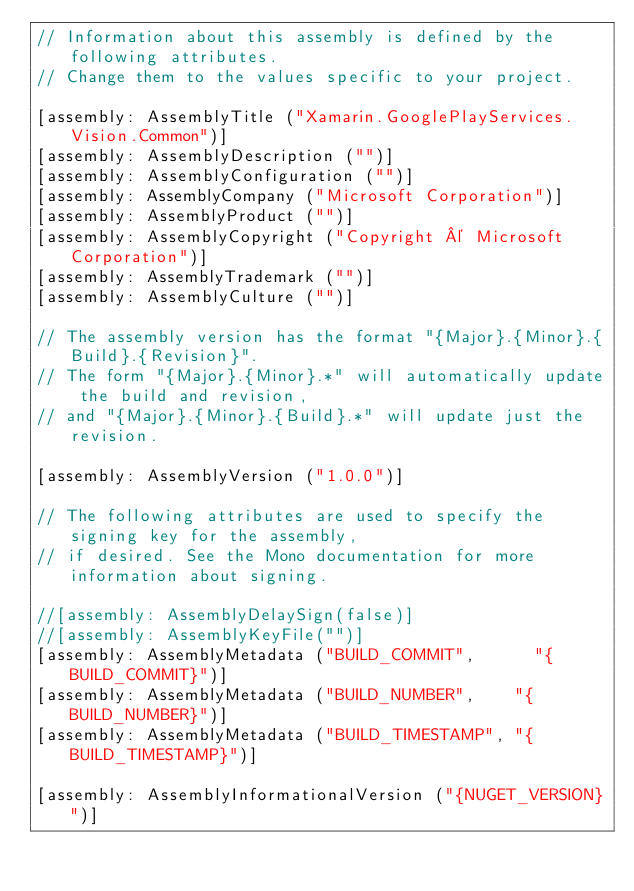<code> <loc_0><loc_0><loc_500><loc_500><_C#_>// Information about this assembly is defined by the following attributes.
// Change them to the values specific to your project.

[assembly: AssemblyTitle ("Xamarin.GooglePlayServices.Vision.Common")]
[assembly: AssemblyDescription ("")]
[assembly: AssemblyConfiguration ("")]
[assembly: AssemblyCompany ("Microsoft Corporation")]
[assembly: AssemblyProduct ("")]
[assembly: AssemblyCopyright ("Copyright © Microsoft Corporation")]
[assembly: AssemblyTrademark ("")]
[assembly: AssemblyCulture ("")]

// The assembly version has the format "{Major}.{Minor}.{Build}.{Revision}".
// The form "{Major}.{Minor}.*" will automatically update the build and revision,
// and "{Major}.{Minor}.{Build}.*" will update just the revision.

[assembly: AssemblyVersion ("1.0.0")]

// The following attributes are used to specify the signing key for the assembly,
// if desired. See the Mono documentation for more information about signing.

//[assembly: AssemblyDelaySign(false)]
//[assembly: AssemblyKeyFile("")]
[assembly: AssemblyMetadata ("BUILD_COMMIT",      "{BUILD_COMMIT}")]
[assembly: AssemblyMetadata ("BUILD_NUMBER",    "{BUILD_NUMBER}")]
[assembly: AssemblyMetadata ("BUILD_TIMESTAMP", "{BUILD_TIMESTAMP}")]

[assembly: AssemblyInformationalVersion ("{NUGET_VERSION}")]
</code> 